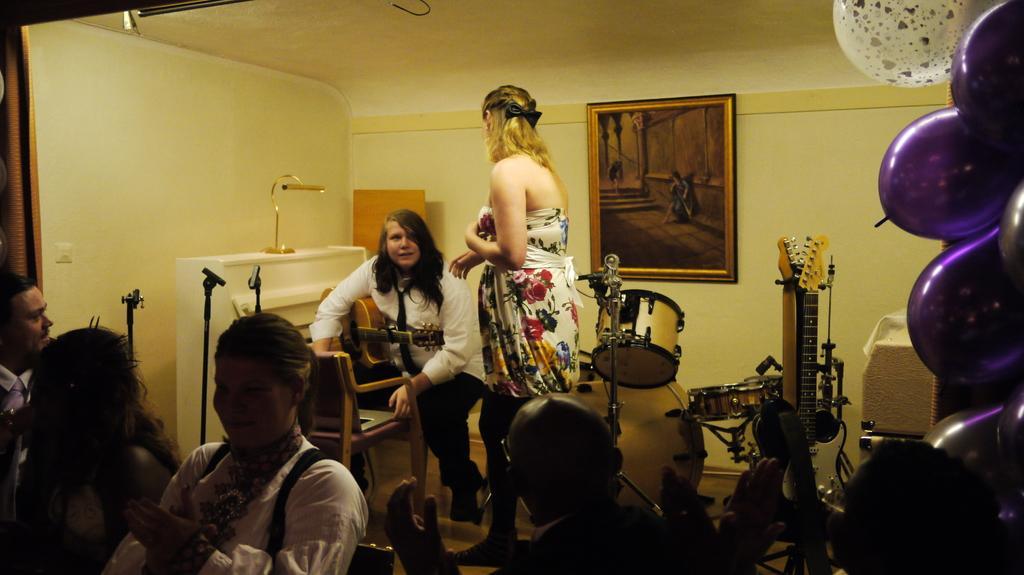Please provide a concise description of this image. In this picture we can see group of people, on the right side of the image we can find balloons and musical instruments, in the background we can see a frame on the wall, in the middle of the image we can see a woman, she is seated on the chair, in front of her we can see a laptop. 